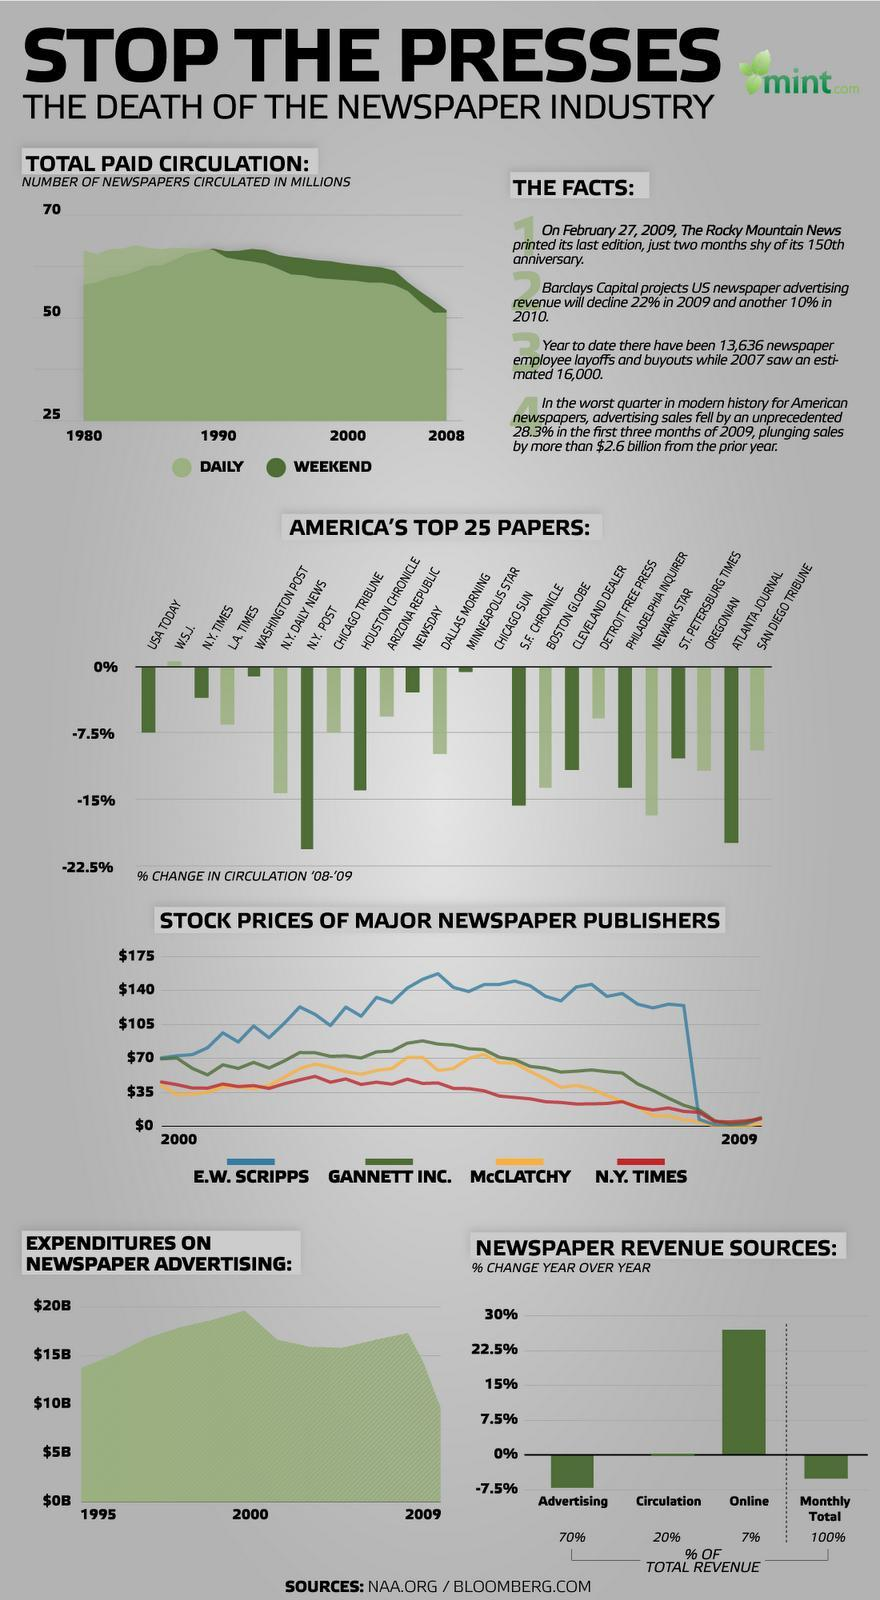What percentage of newspaper revenue is from online and circulation, taken together?
Answer the question with a short phrase. 27% What percentage of newspaper revenue is from advertising and circulation, taken together? 90% 